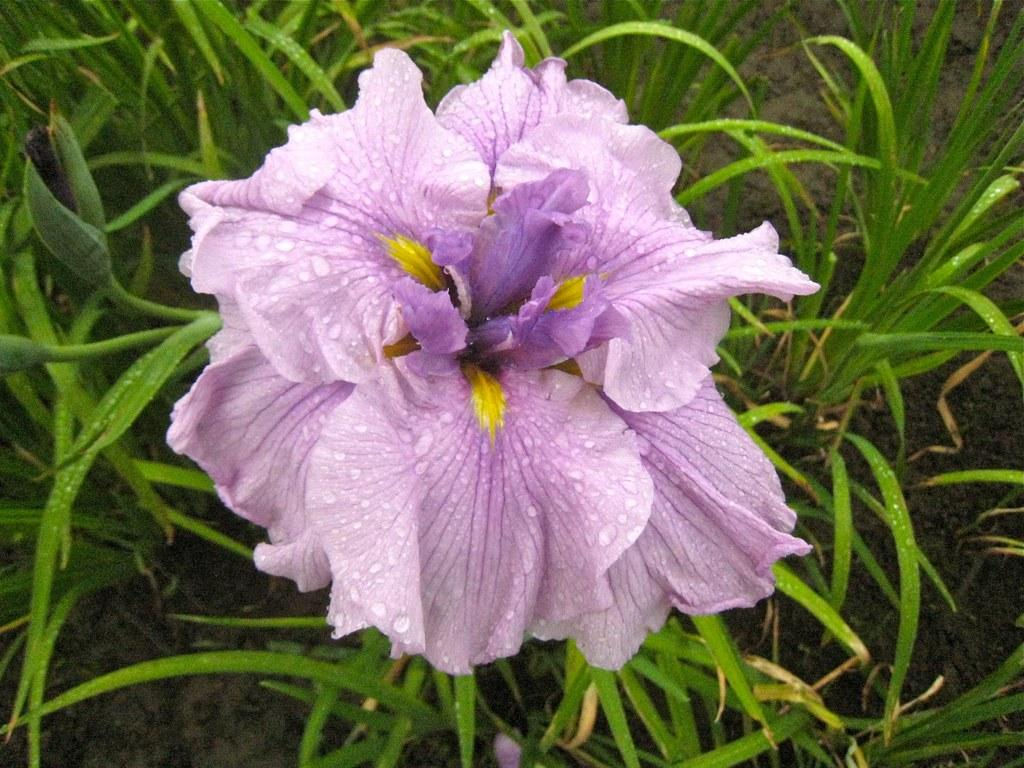What type of flower can be seen on a plant in the image? There is a purple flower on a plant in the image. Are there any other plants visible in the image? Yes, there are other plants in the image. What can be seen at the bottom of the image? The ground is visible at the bottom of the image. How many chairs are present in the image? There are no chairs visible in the image. 